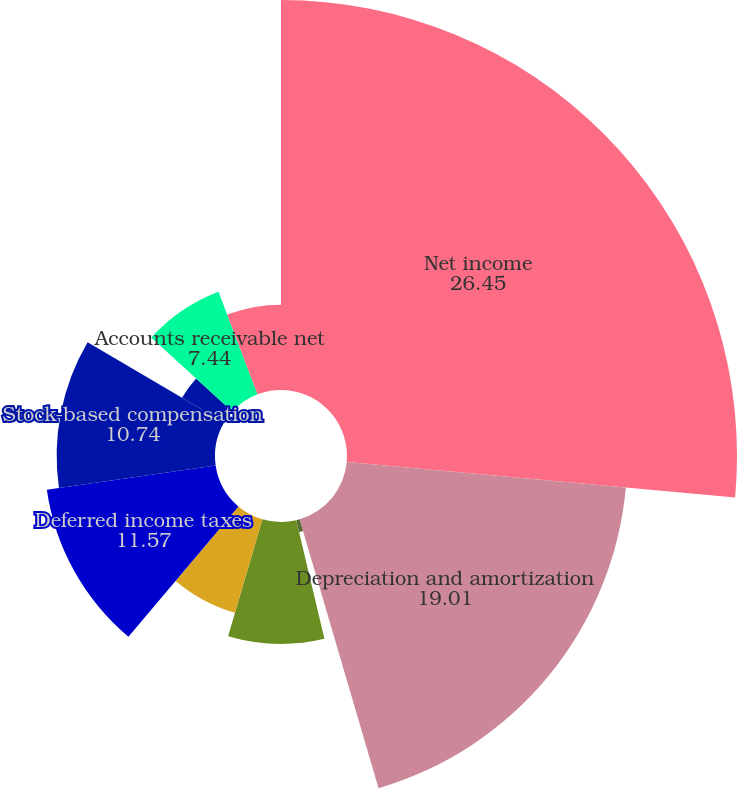<chart> <loc_0><loc_0><loc_500><loc_500><pie_chart><fcel>Net income<fcel>Depreciation and amortization<fcel>Amortization of debt discount<fcel>Acquisition-related items<fcel>Provision for doubtful<fcel>Deferred income taxes<fcel>Stock-based compensation<fcel>Other net<fcel>Accounts receivable net<fcel>Inventories<nl><fcel>26.45%<fcel>19.01%<fcel>0.83%<fcel>8.26%<fcel>6.61%<fcel>11.57%<fcel>10.74%<fcel>3.31%<fcel>7.44%<fcel>5.79%<nl></chart> 